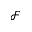Convert formula to latex. <formula><loc_0><loc_0><loc_500><loc_500>\mathcal { F }</formula> 